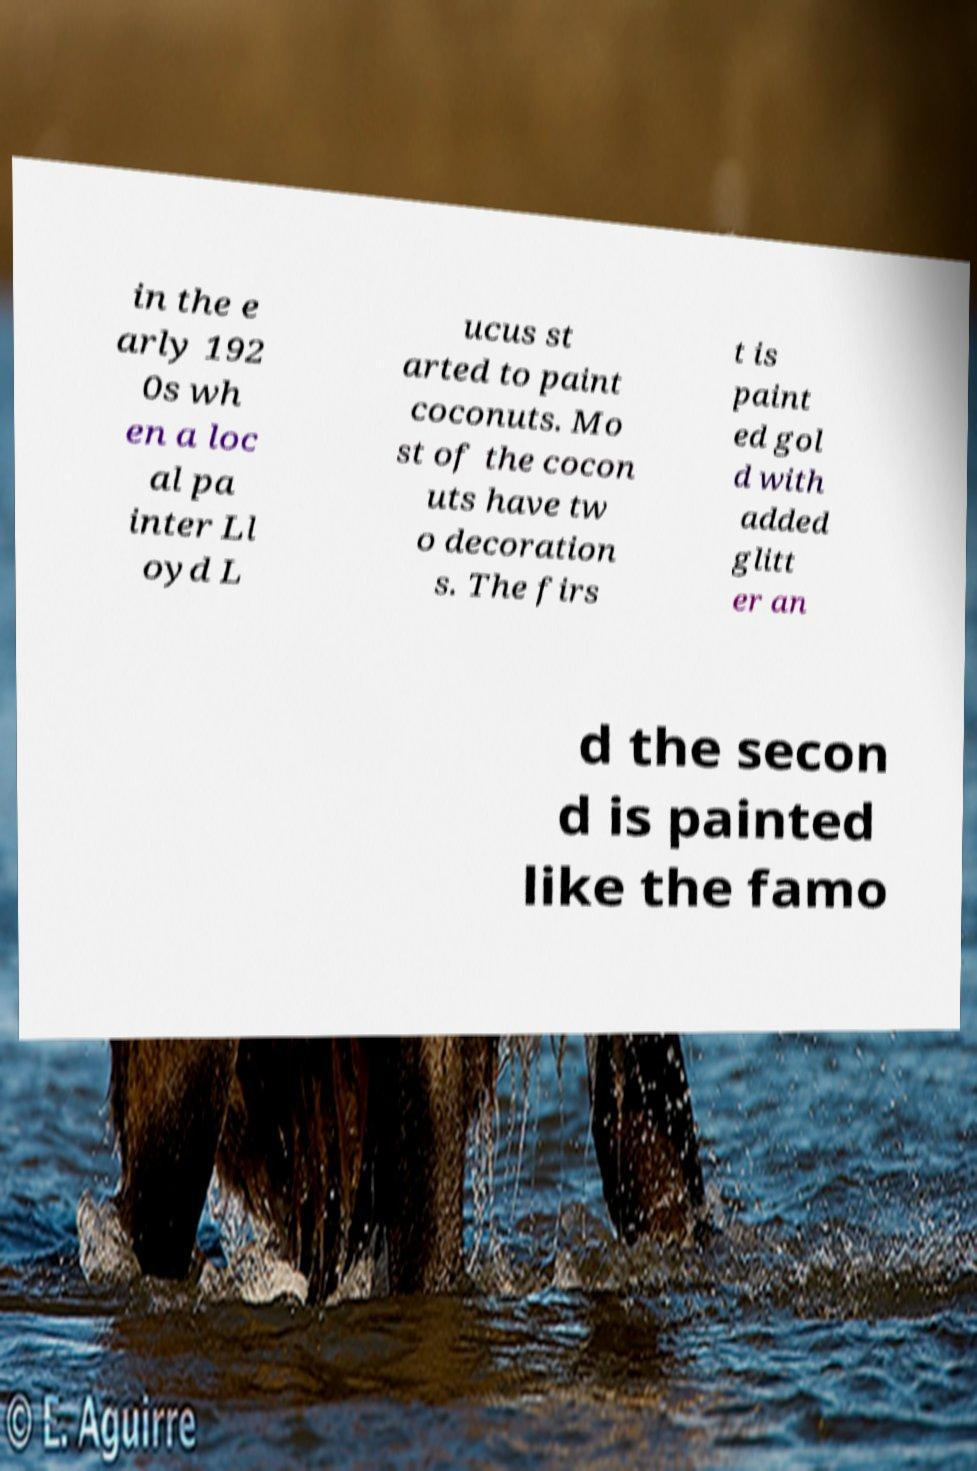Please identify and transcribe the text found in this image. in the e arly 192 0s wh en a loc al pa inter Ll oyd L ucus st arted to paint coconuts. Mo st of the cocon uts have tw o decoration s. The firs t is paint ed gol d with added glitt er an d the secon d is painted like the famo 